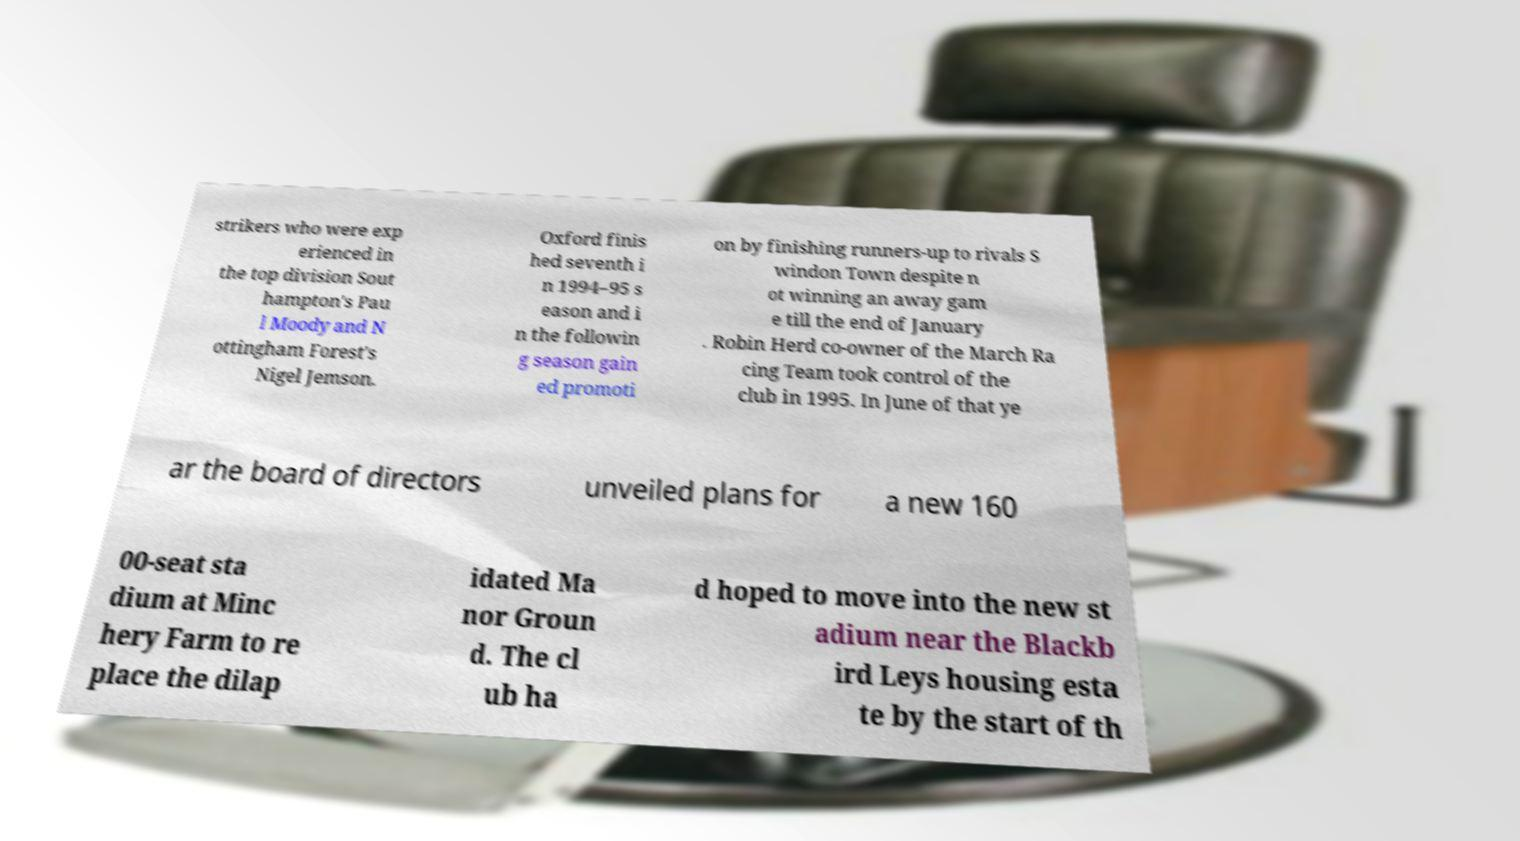There's text embedded in this image that I need extracted. Can you transcribe it verbatim? strikers who were exp erienced in the top division Sout hampton's Pau l Moody and N ottingham Forest's Nigel Jemson. Oxford finis hed seventh i n 1994–95 s eason and i n the followin g season gain ed promoti on by finishing runners-up to rivals S windon Town despite n ot winning an away gam e till the end of January . Robin Herd co-owner of the March Ra cing Team took control of the club in 1995. In June of that ye ar the board of directors unveiled plans for a new 160 00-seat sta dium at Minc hery Farm to re place the dilap idated Ma nor Groun d. The cl ub ha d hoped to move into the new st adium near the Blackb ird Leys housing esta te by the start of th 